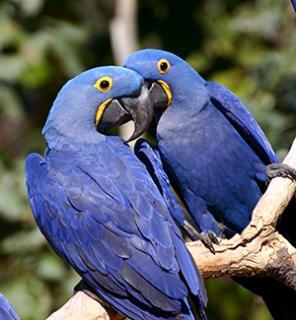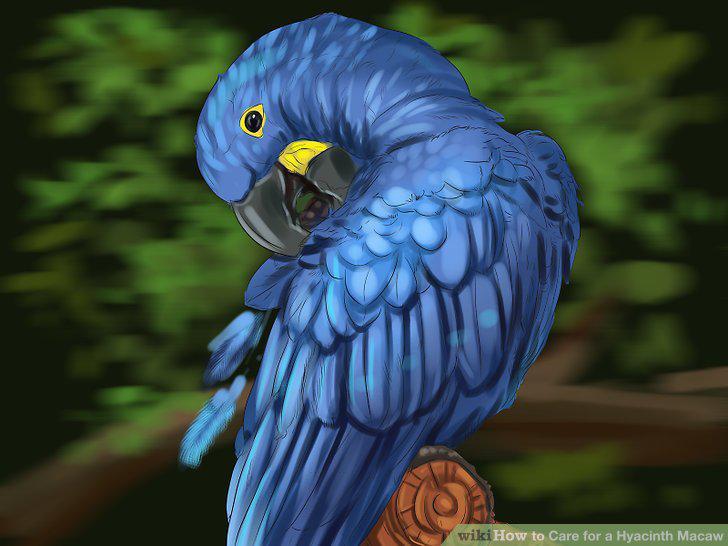The first image is the image on the left, the second image is the image on the right. Examine the images to the left and right. Is the description "In at least one image, a single bird is pictured that lacks a yellow ring around the eye and has a small straight beak." accurate? Answer yes or no. No. The first image is the image on the left, the second image is the image on the right. Considering the images on both sides, is "All images show a blue-feathered bird perched on something resembling wood." valid? Answer yes or no. Yes. 